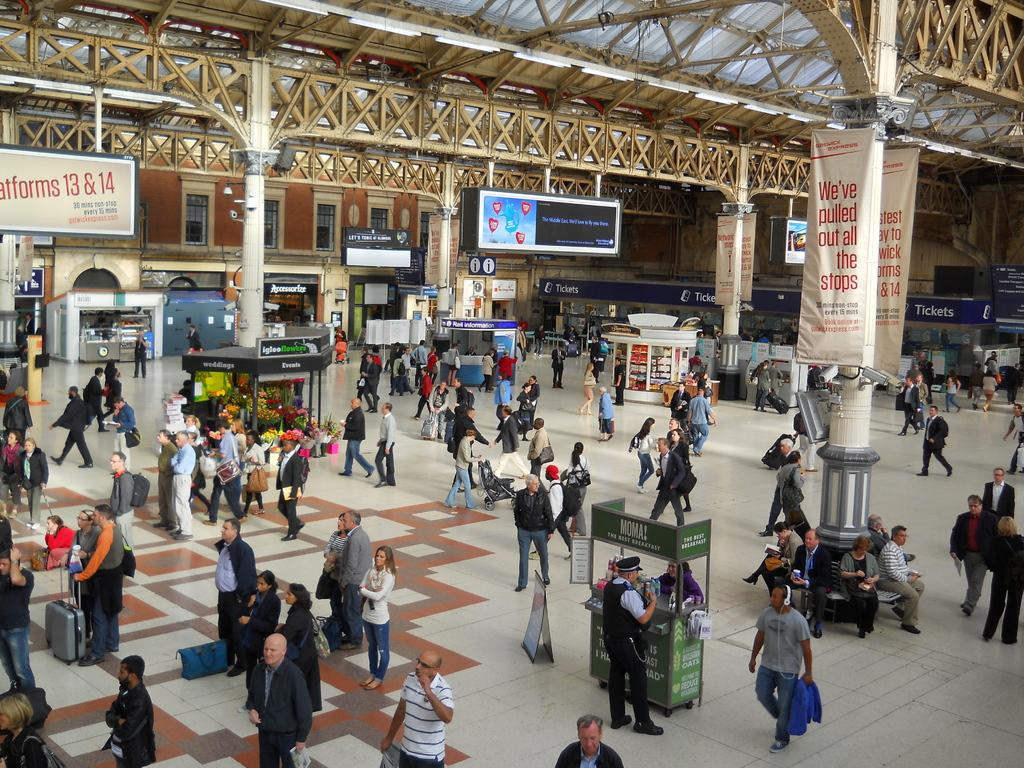<image>
Present a compact description of the photo's key features. A busy railway station has an Igloo Flowers shop in the middle. 